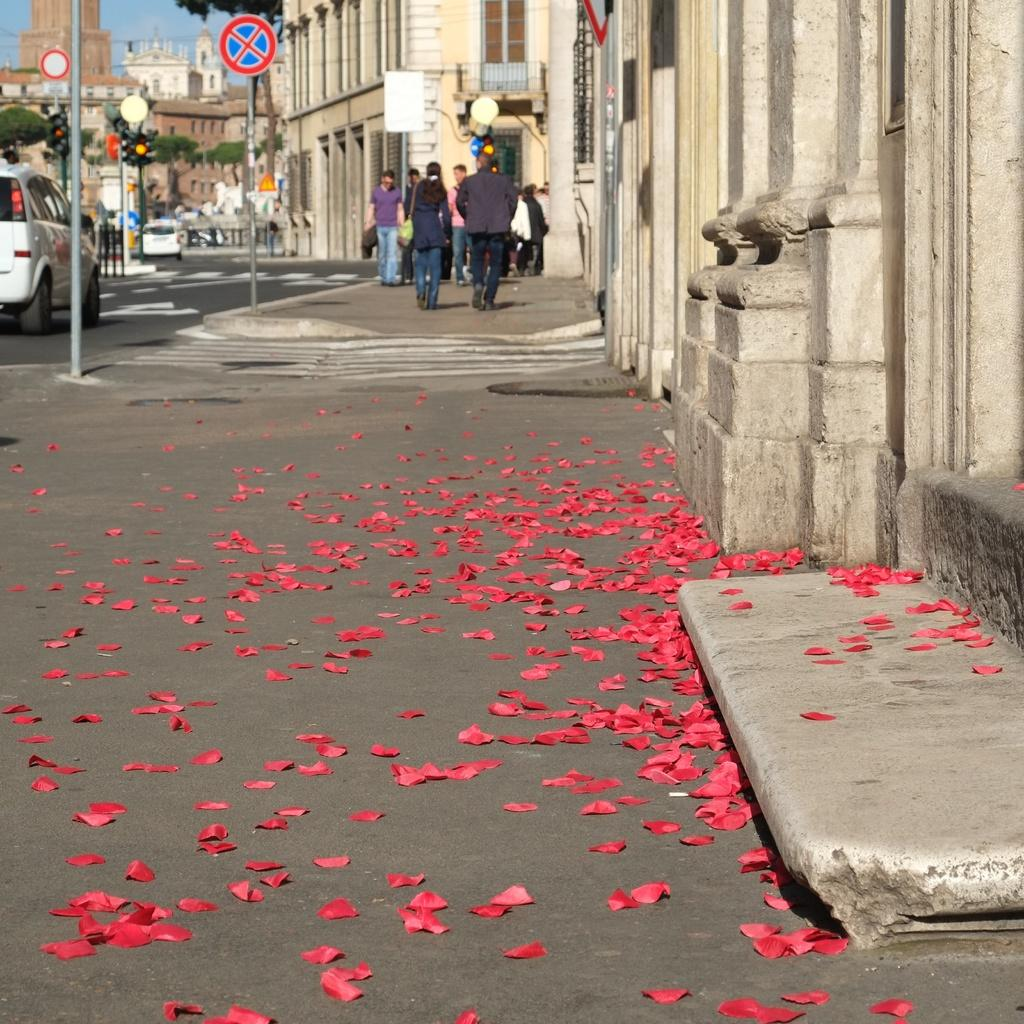How many people are in the image? There is a group of people in the image, but the exact number is not specified. What are the people in the image doing? Some people are standing, while others are walking. What else can be seen in the image besides people? There are vehicles, traffic signals, poles, buildings, and a blue sky visible in the image. What type of vehicles are present in the image? The facts do not specify the type of vehicles in the image. What type of produce is being harvested by the giants in the image? There are no giants present in the image, and therefore no produce is being harvested. What stage of development is the city in, as seen in the image? The facts do not provide information about the development stage of the city or buildings in the image. 